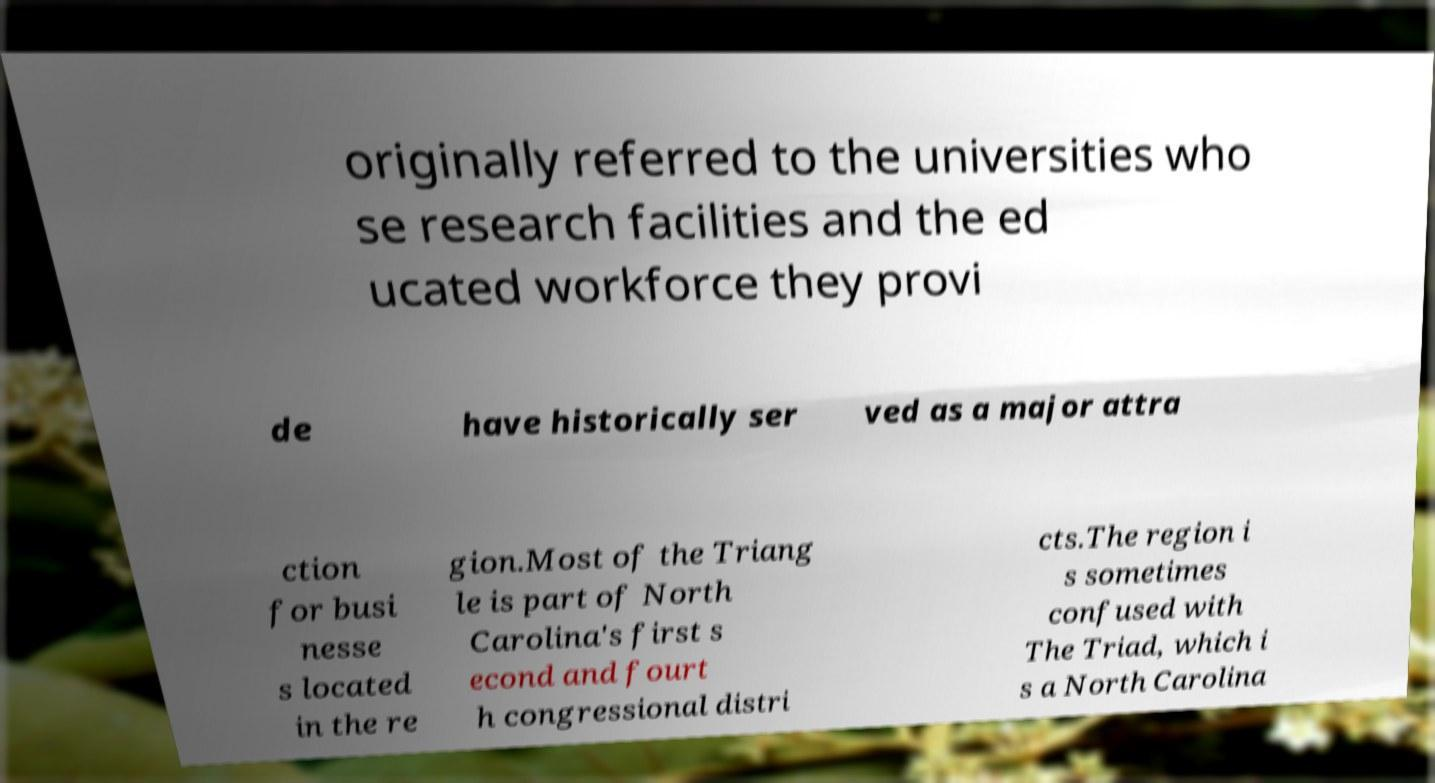For documentation purposes, I need the text within this image transcribed. Could you provide that? originally referred to the universities who se research facilities and the ed ucated workforce they provi de have historically ser ved as a major attra ction for busi nesse s located in the re gion.Most of the Triang le is part of North Carolina's first s econd and fourt h congressional distri cts.The region i s sometimes confused with The Triad, which i s a North Carolina 